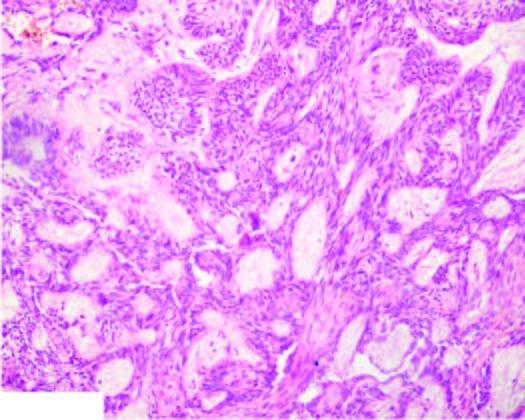what are epithelial follicles composed of?
Answer the question using a single word or phrase. Central area of stellate cells and peripheral layer cuboidal or columnar cells 